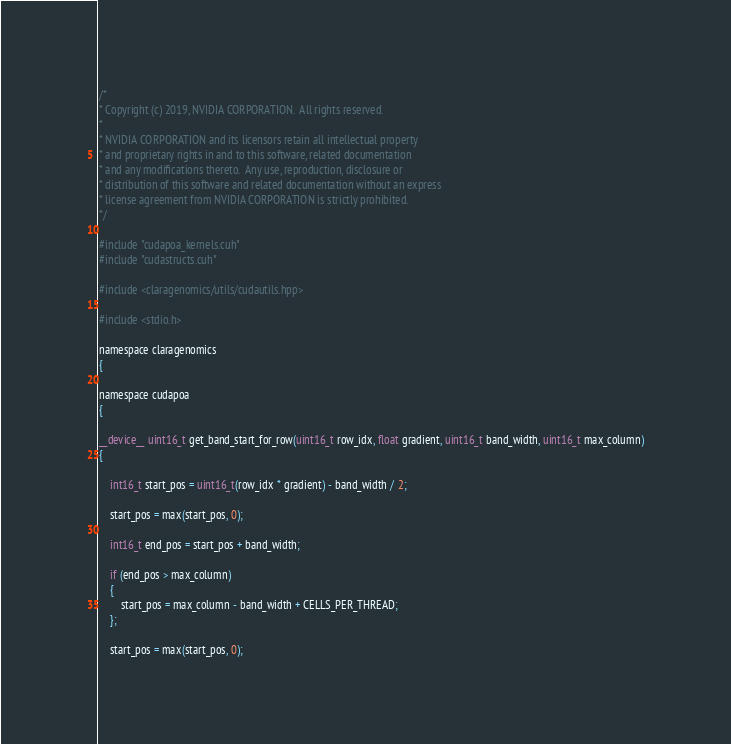Convert code to text. <code><loc_0><loc_0><loc_500><loc_500><_Cuda_>/*
* Copyright (c) 2019, NVIDIA CORPORATION.  All rights reserved.
*
* NVIDIA CORPORATION and its licensors retain all intellectual property
* and proprietary rights in and to this software, related documentation
* and any modifications thereto.  Any use, reproduction, disclosure or
* distribution of this software and related documentation without an express
* license agreement from NVIDIA CORPORATION is strictly prohibited.
*/

#include "cudapoa_kernels.cuh"
#include "cudastructs.cuh"

#include <claragenomics/utils/cudautils.hpp>

#include <stdio.h>

namespace claragenomics
{

namespace cudapoa
{

__device__ uint16_t get_band_start_for_row(uint16_t row_idx, float gradient, uint16_t band_width, uint16_t max_column)
{

    int16_t start_pos = uint16_t(row_idx * gradient) - band_width / 2;

    start_pos = max(start_pos, 0);

    int16_t end_pos = start_pos + band_width;

    if (end_pos > max_column)
    {
        start_pos = max_column - band_width + CELLS_PER_THREAD;
    };

    start_pos = max(start_pos, 0);
</code> 